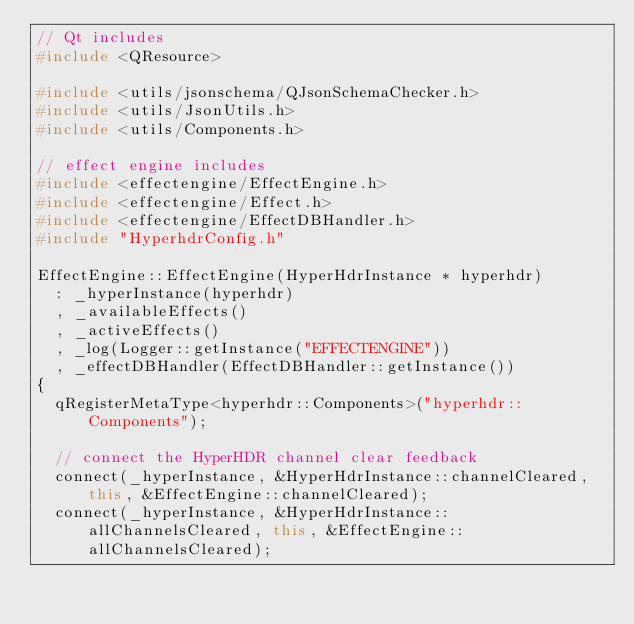Convert code to text. <code><loc_0><loc_0><loc_500><loc_500><_C++_>// Qt includes
#include <QResource>

#include <utils/jsonschema/QJsonSchemaChecker.h>
#include <utils/JsonUtils.h>
#include <utils/Components.h>

// effect engine includes
#include <effectengine/EffectEngine.h>
#include <effectengine/Effect.h>
#include <effectengine/EffectDBHandler.h>
#include "HyperhdrConfig.h"

EffectEngine::EffectEngine(HyperHdrInstance * hyperhdr)
	: _hyperInstance(hyperhdr)
	, _availableEffects()
	, _activeEffects()
	, _log(Logger::getInstance("EFFECTENGINE"))
	, _effectDBHandler(EffectDBHandler::getInstance())
{	
	qRegisterMetaType<hyperhdr::Components>("hyperhdr::Components");

	// connect the HyperHDR channel clear feedback
	connect(_hyperInstance, &HyperHdrInstance::channelCleared, this, &EffectEngine::channelCleared);
	connect(_hyperInstance, &HyperHdrInstance::allChannelsCleared, this, &EffectEngine::allChannelsCleared);
</code> 